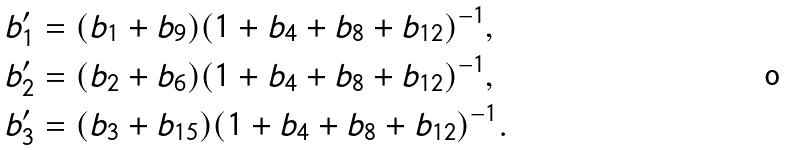Convert formula to latex. <formula><loc_0><loc_0><loc_500><loc_500>& b ^ { \prime } _ { 1 } = ( b _ { 1 } + b _ { 9 } ) ( 1 + b _ { 4 } + b _ { 8 } + b _ { 1 2 } ) ^ { - 1 } , \\ & b ^ { \prime } _ { 2 } = ( b _ { 2 } + b _ { 6 } ) ( 1 + b _ { 4 } + b _ { 8 } + b _ { 1 2 } ) ^ { - 1 } , \\ & b ^ { \prime } _ { 3 } = ( b _ { 3 } + b _ { 1 5 } ) ( 1 + b _ { 4 } + b _ { 8 } + b _ { 1 2 } ) ^ { - 1 } .</formula> 